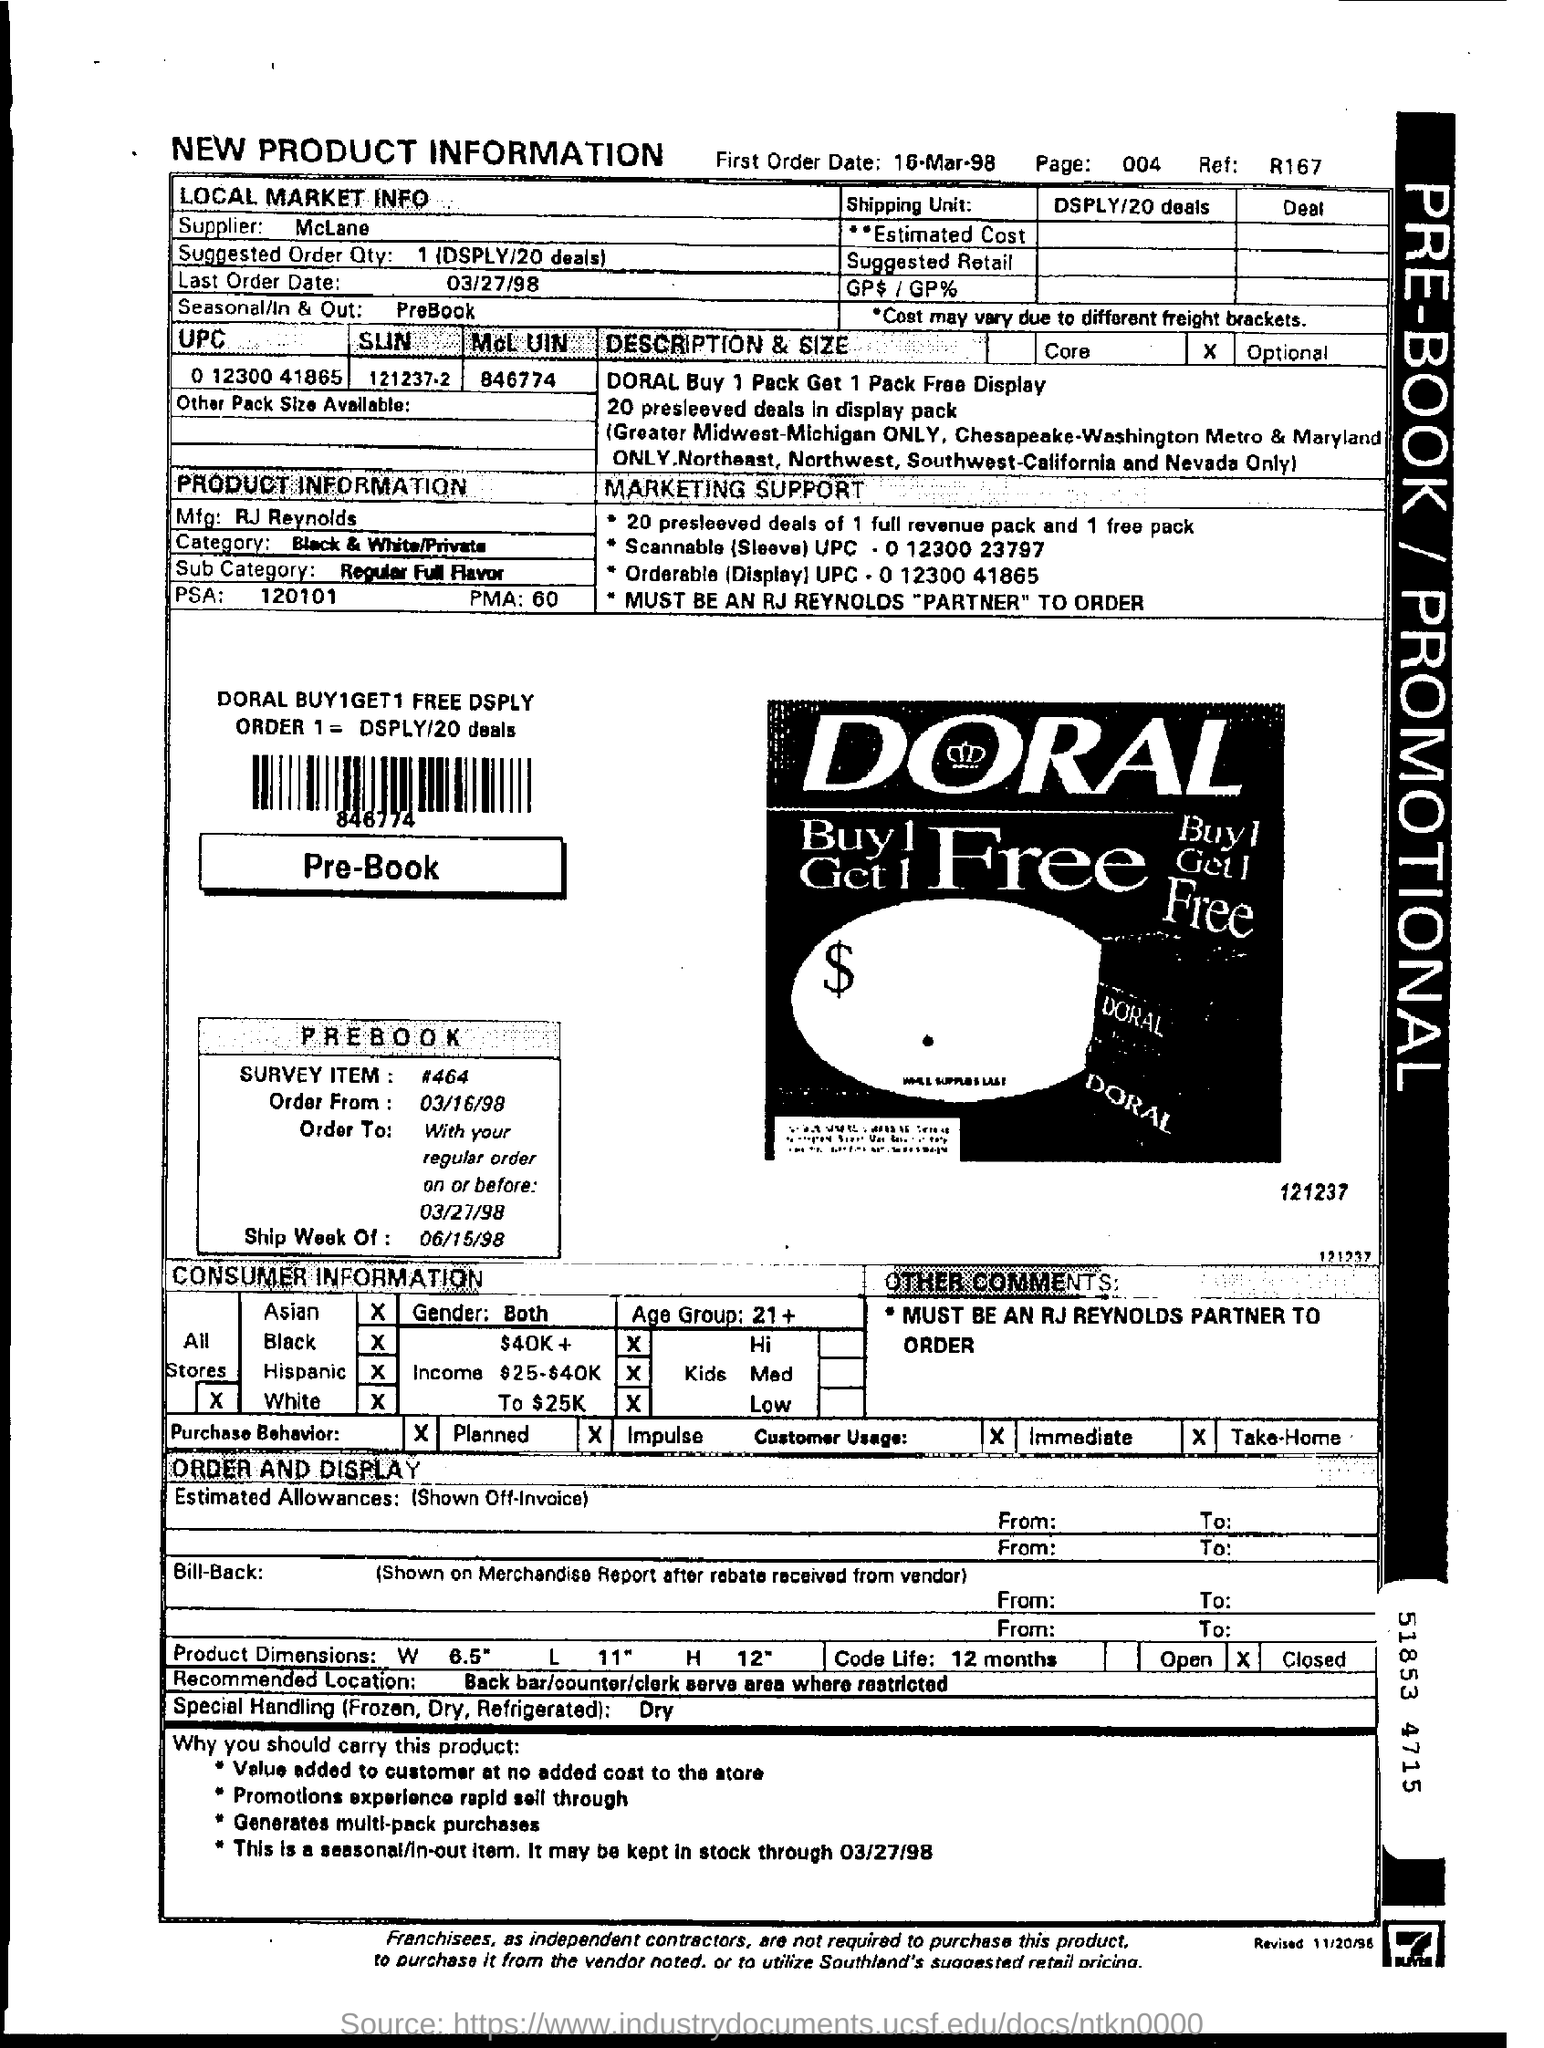Point out several critical features in this image. The manufacturer of the product is RJ Reynolds. The PMA number of the product is 60. What is the recommended order quantity? This information is displayed on deal 20. The product belongs to the category of Black & White/Private. The first order date is March 16, 1998. 